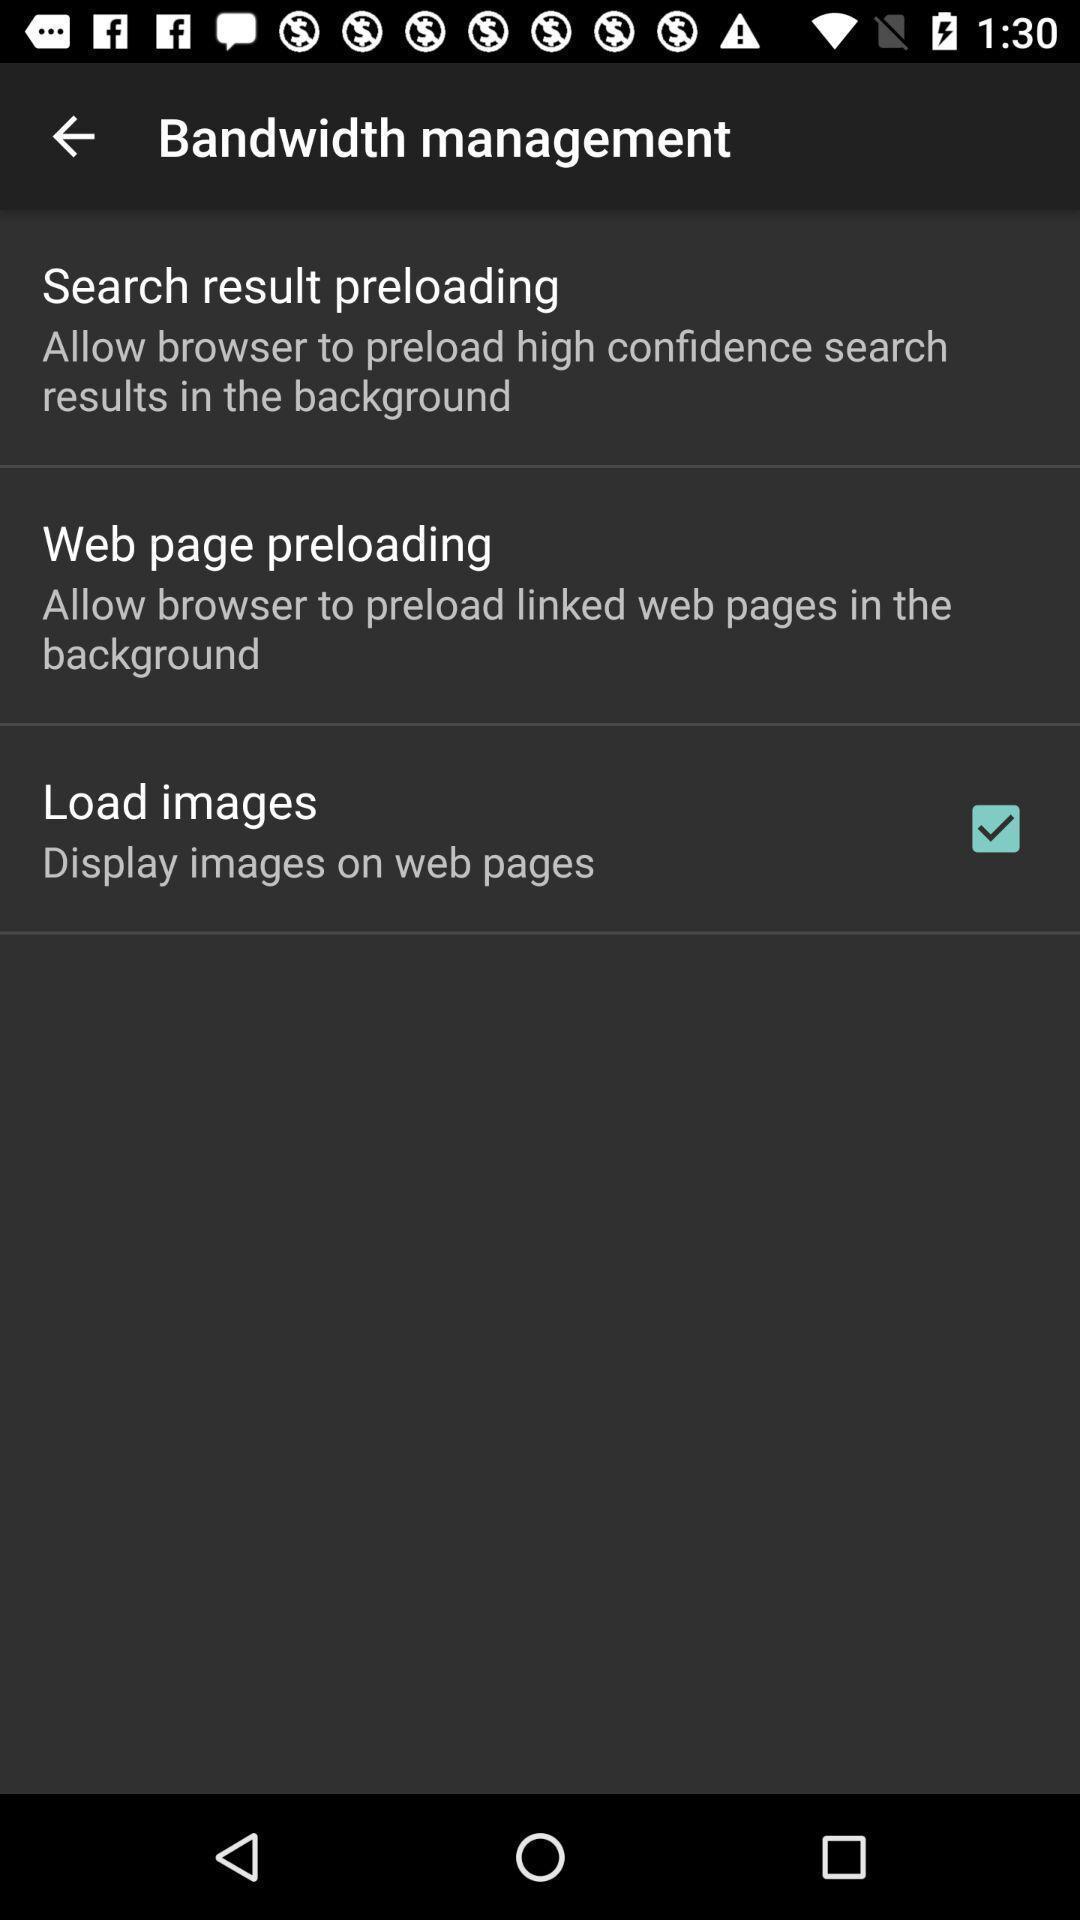Provide a textual representation of this image. Page showing options like search result. 